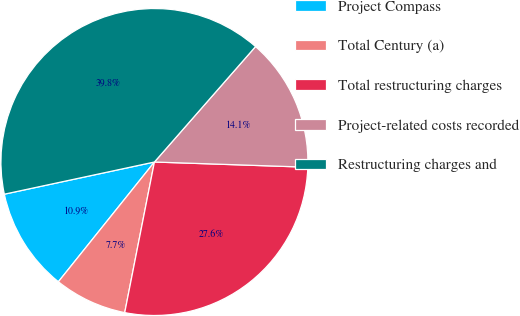<chart> <loc_0><loc_0><loc_500><loc_500><pie_chart><fcel>Project Compass<fcel>Total Century (a)<fcel>Total restructuring charges<fcel>Project-related costs recorded<fcel>Restructuring charges and<nl><fcel>10.88%<fcel>7.66%<fcel>27.56%<fcel>14.09%<fcel>39.81%<nl></chart> 